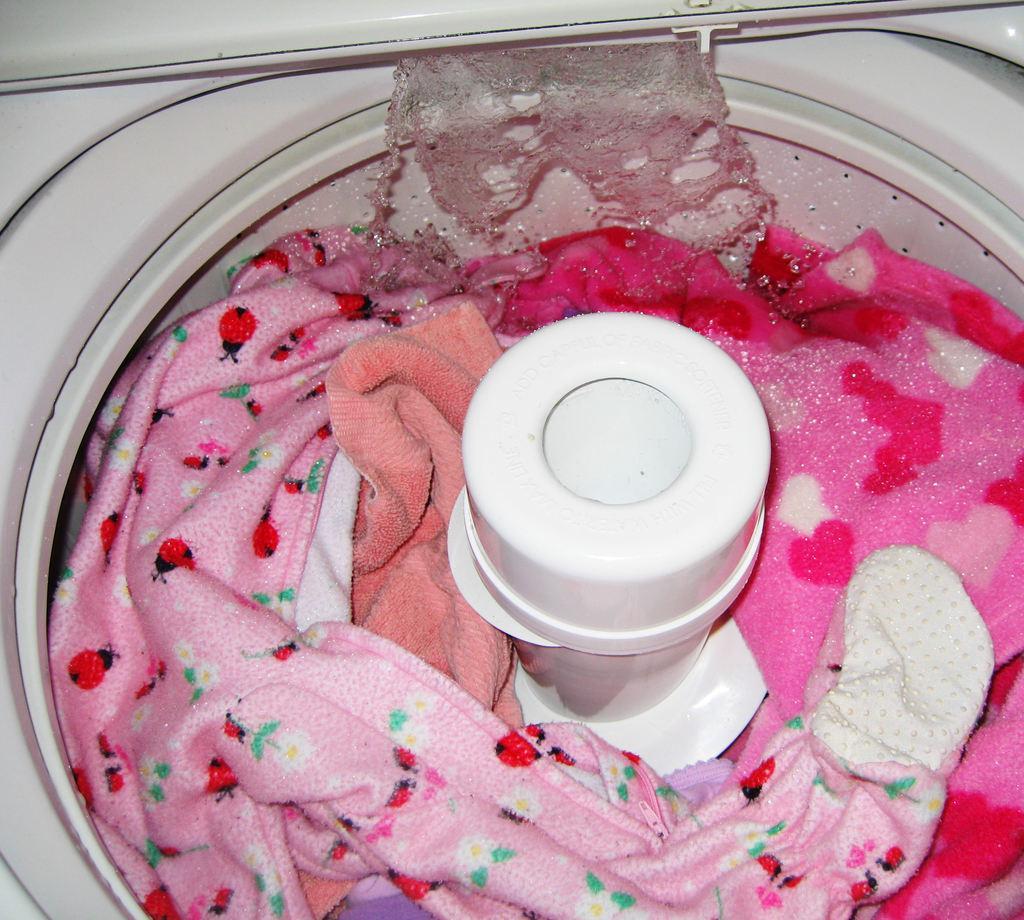In one or two sentences, can you explain what this image depicts? In this image we can see some clothes in the washing machine, also we can see the water. 